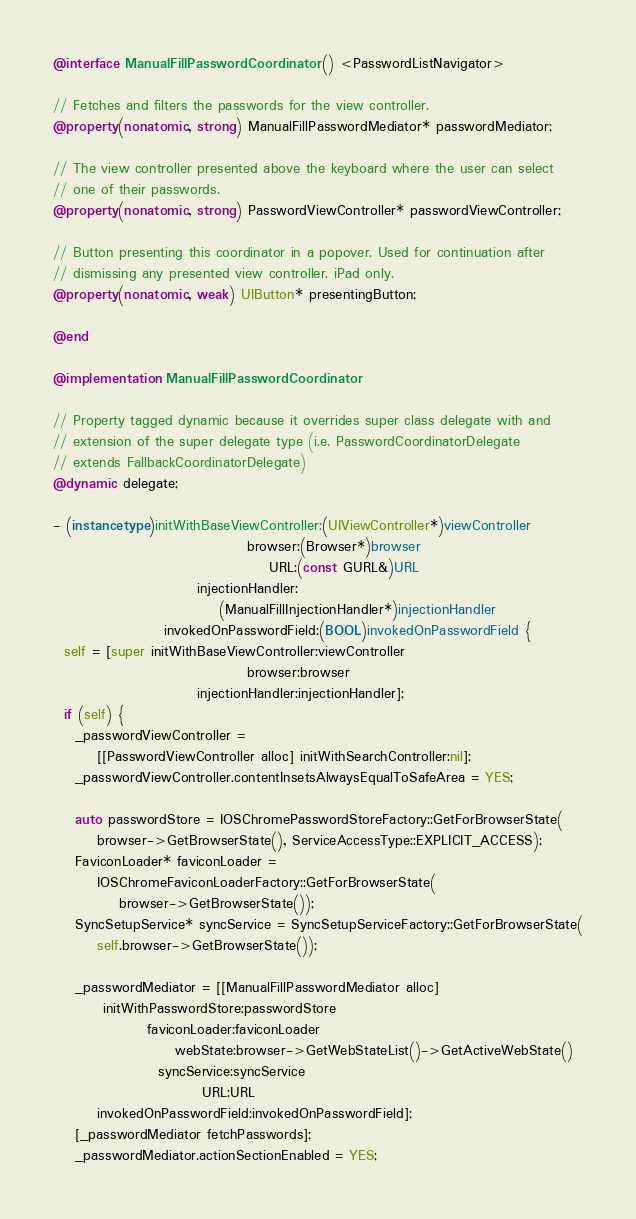<code> <loc_0><loc_0><loc_500><loc_500><_ObjectiveC_>@interface ManualFillPasswordCoordinator () <PasswordListNavigator>

// Fetches and filters the passwords for the view controller.
@property(nonatomic, strong) ManualFillPasswordMediator* passwordMediator;

// The view controller presented above the keyboard where the user can select
// one of their passwords.
@property(nonatomic, strong) PasswordViewController* passwordViewController;

// Button presenting this coordinator in a popover. Used for continuation after
// dismissing any presented view controller. iPad only.
@property(nonatomic, weak) UIButton* presentingButton;

@end

@implementation ManualFillPasswordCoordinator

// Property tagged dynamic because it overrides super class delegate with and
// extension of the super delegate type (i.e. PasswordCoordinatorDelegate
// extends FallbackCoordinatorDelegate)
@dynamic delegate;

- (instancetype)initWithBaseViewController:(UIViewController*)viewController
                                   browser:(Browser*)browser
                                       URL:(const GURL&)URL
                          injectionHandler:
                              (ManualFillInjectionHandler*)injectionHandler
                    invokedOnPasswordField:(BOOL)invokedOnPasswordField {
  self = [super initWithBaseViewController:viewController
                                   browser:browser
                          injectionHandler:injectionHandler];
  if (self) {
    _passwordViewController =
        [[PasswordViewController alloc] initWithSearchController:nil];
    _passwordViewController.contentInsetsAlwaysEqualToSafeArea = YES;

    auto passwordStore = IOSChromePasswordStoreFactory::GetForBrowserState(
        browser->GetBrowserState(), ServiceAccessType::EXPLICIT_ACCESS);
    FaviconLoader* faviconLoader =
        IOSChromeFaviconLoaderFactory::GetForBrowserState(
            browser->GetBrowserState());
    SyncSetupService* syncService = SyncSetupServiceFactory::GetForBrowserState(
        self.browser->GetBrowserState());

    _passwordMediator = [[ManualFillPasswordMediator alloc]
         initWithPasswordStore:passwordStore
                 faviconLoader:faviconLoader
                      webState:browser->GetWebStateList()->GetActiveWebState()
                   syncService:syncService
                           URL:URL
        invokedOnPasswordField:invokedOnPasswordField];
    [_passwordMediator fetchPasswords];
    _passwordMediator.actionSectionEnabled = YES;</code> 